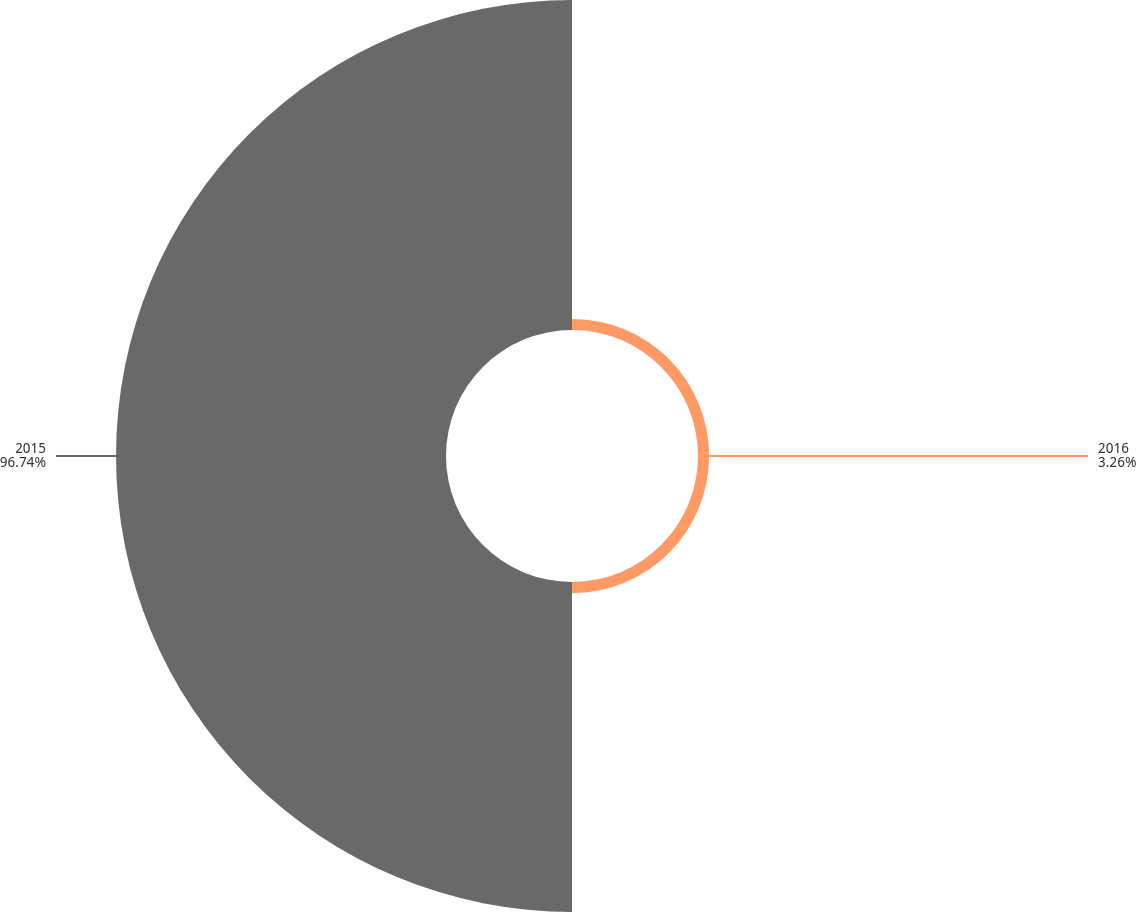Convert chart to OTSL. <chart><loc_0><loc_0><loc_500><loc_500><pie_chart><fcel>2016<fcel>2015<nl><fcel>3.26%<fcel>96.74%<nl></chart> 